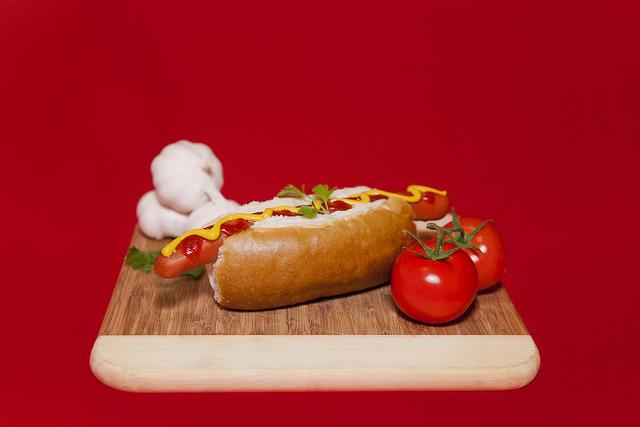What meal is this for?
Write a very short answer. Lunch. What kind of garnish is on the entree?
Short answer required. Parsley. Where are the hot dogs?
Quick response, please. On board. What are the green things?
Answer briefly. Parsley. Is this hot dog made out of cake?
Keep it brief. No. Who is going to eat this hot dog?
Answer briefly. Adult. What is the plate made of?
Write a very short answer. Wood. What is on the hotdog?
Answer briefly. Mustard and ketchup. What color is the table top?
Concise answer only. Red. What is the hot dog on top of?
Be succinct. Cutting board. 